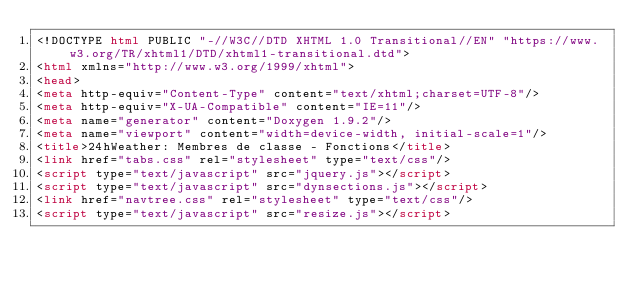Convert code to text. <code><loc_0><loc_0><loc_500><loc_500><_HTML_><!DOCTYPE html PUBLIC "-//W3C//DTD XHTML 1.0 Transitional//EN" "https://www.w3.org/TR/xhtml1/DTD/xhtml1-transitional.dtd">
<html xmlns="http://www.w3.org/1999/xhtml">
<head>
<meta http-equiv="Content-Type" content="text/xhtml;charset=UTF-8"/>
<meta http-equiv="X-UA-Compatible" content="IE=11"/>
<meta name="generator" content="Doxygen 1.9.2"/>
<meta name="viewport" content="width=device-width, initial-scale=1"/>
<title>24hWeather: Membres de classe - Fonctions</title>
<link href="tabs.css" rel="stylesheet" type="text/css"/>
<script type="text/javascript" src="jquery.js"></script>
<script type="text/javascript" src="dynsections.js"></script>
<link href="navtree.css" rel="stylesheet" type="text/css"/>
<script type="text/javascript" src="resize.js"></script></code> 